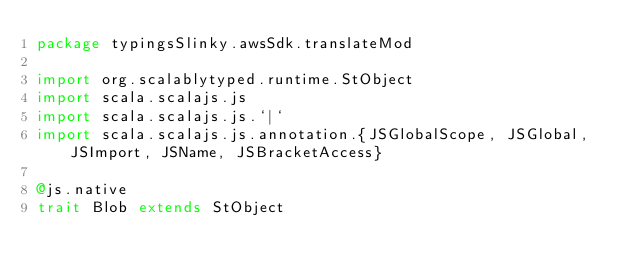<code> <loc_0><loc_0><loc_500><loc_500><_Scala_>package typingsSlinky.awsSdk.translateMod

import org.scalablytyped.runtime.StObject
import scala.scalajs.js
import scala.scalajs.js.`|`
import scala.scalajs.js.annotation.{JSGlobalScope, JSGlobal, JSImport, JSName, JSBracketAccess}

@js.native
trait Blob extends StObject
</code> 